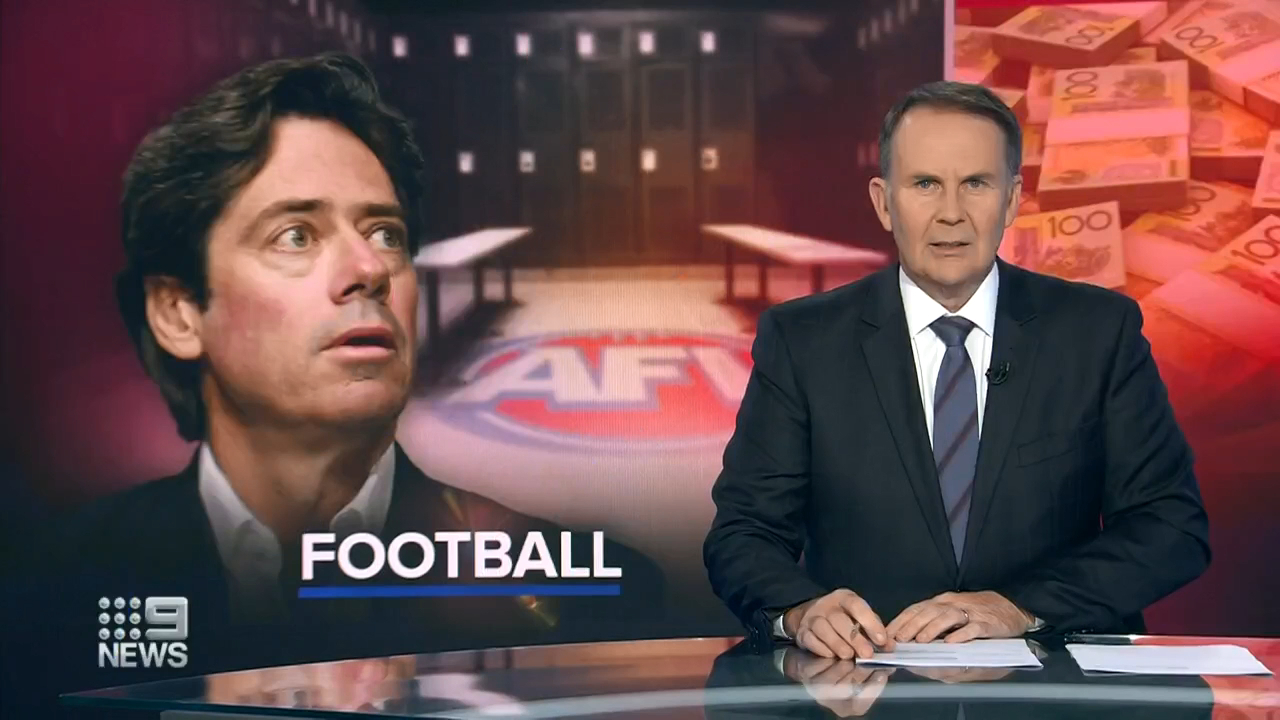What specific issue do you think the news anchor is discussing, based on the visual cues? Given the visual cues in the image, the news anchor might be discussing a significant financial issue within Australian Football. The background graphic showing a concerned individual juxtaposed with stacks of currency suggests that this issue could relate to financial troubles, possibly corruption, budget cuts, or a financial scandal affecting the sport. 